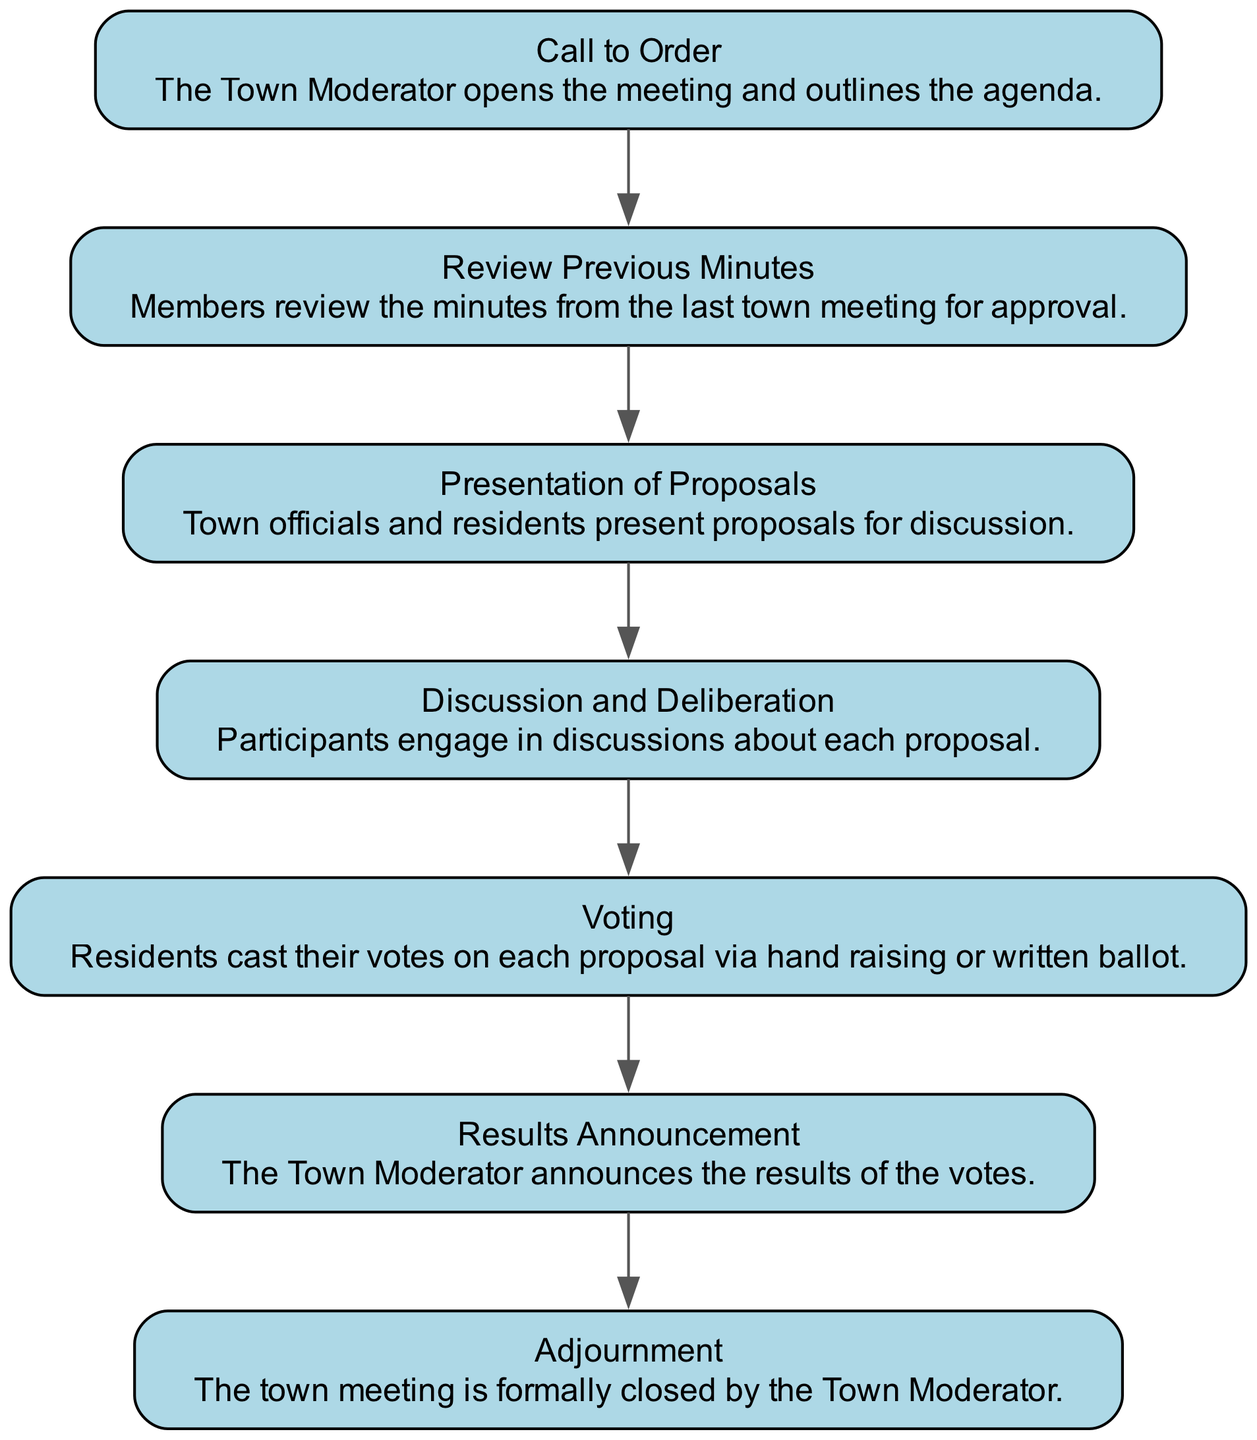What is the first step in the process? The first step in the diagram is labeled "Call to Order," which indicates that the Town Moderator opens the meeting and outlines the agenda. This is the starting point of the decision-making process.
Answer: Call to Order How many total nodes are in the diagram? By counting the individual steps in the decision-making process outlined in the diagram, there are a total of seven distinct nodes present.
Answer: Seven What happens after "Presentation of Proposals"? Following the "Presentation of Proposals," the next step according to the flow is "Discussion and Deliberation," where participants engage in discussions about each proposal. This shows the logical progression from one activity to the next.
Answer: Discussion and Deliberation What is the last step before adjournment? The final step prior to adjournment is "Results Announcement," where the Town Moderator announces the results of the votes. This serves as a crucial conclusion to the decision-making activities before the meeting is closed.
Answer: Results Announcement Which step involves casting votes? The step specifically related to voting is labeled "Voting," where residents cast their votes on each proposal via hand raising or written ballot. This step indicates the active participation of the residents in the decision-making process.
Answer: Voting How do the proposals move through the process? Proposals move through the process sequentially, starting from "Presentation of Proposals" to "Discussion and Deliberation," then to "Voting," and finally culminating in "Results Announcement." Each step builds upon the previous one, creating a structured flow of decision-making activities.
Answer: Sequentially What role does the Town Moderator play in the process? The Town Moderator's role is central, as they open the meeting, guide the agenda, announce vote results, and subsequently close the meeting. This highlights the Moderator's authority and responsibility throughout the entire process.
Answer: Central role How many discussions occur before voting? There is one step designated for discussion, which is "Discussion and Deliberation," and it occurs directly before the "Voting" step. This indicates that only a single discussion phase is outlined prior to casting votes on the proposals.
Answer: One 